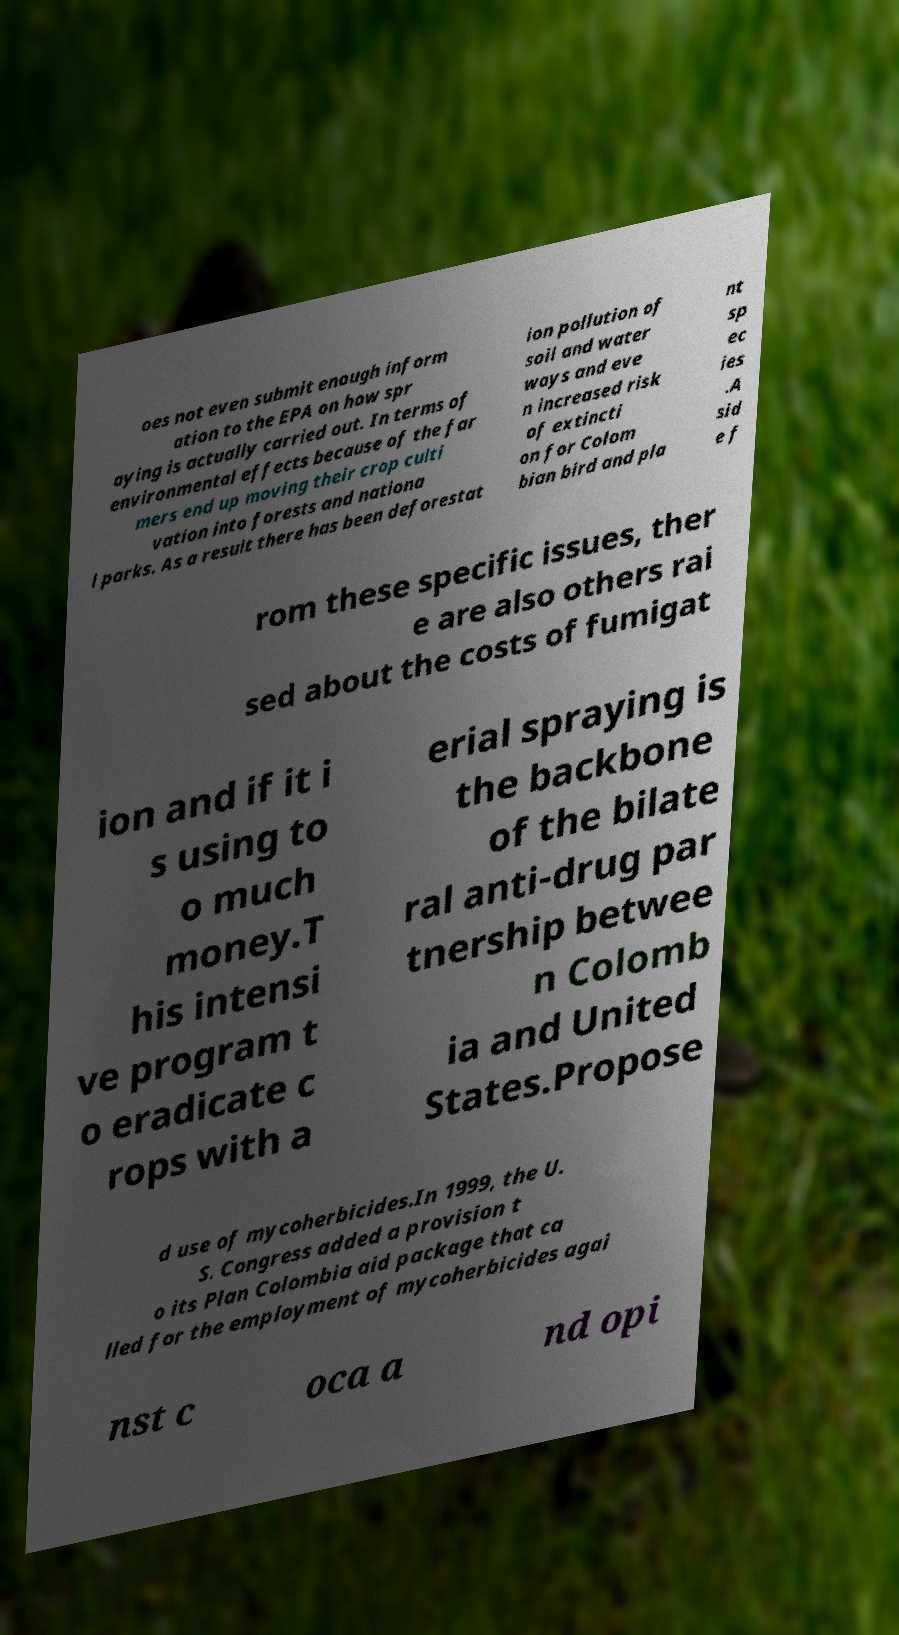Please identify and transcribe the text found in this image. oes not even submit enough inform ation to the EPA on how spr aying is actually carried out. In terms of environmental effects because of the far mers end up moving their crop culti vation into forests and nationa l parks. As a result there has been deforestat ion pollution of soil and water ways and eve n increased risk of extincti on for Colom bian bird and pla nt sp ec ies .A sid e f rom these specific issues, ther e are also others rai sed about the costs of fumigat ion and if it i s using to o much money.T his intensi ve program t o eradicate c rops with a erial spraying is the backbone of the bilate ral anti-drug par tnership betwee n Colomb ia and United States.Propose d use of mycoherbicides.In 1999, the U. S. Congress added a provision t o its Plan Colombia aid package that ca lled for the employment of mycoherbicides agai nst c oca a nd opi 